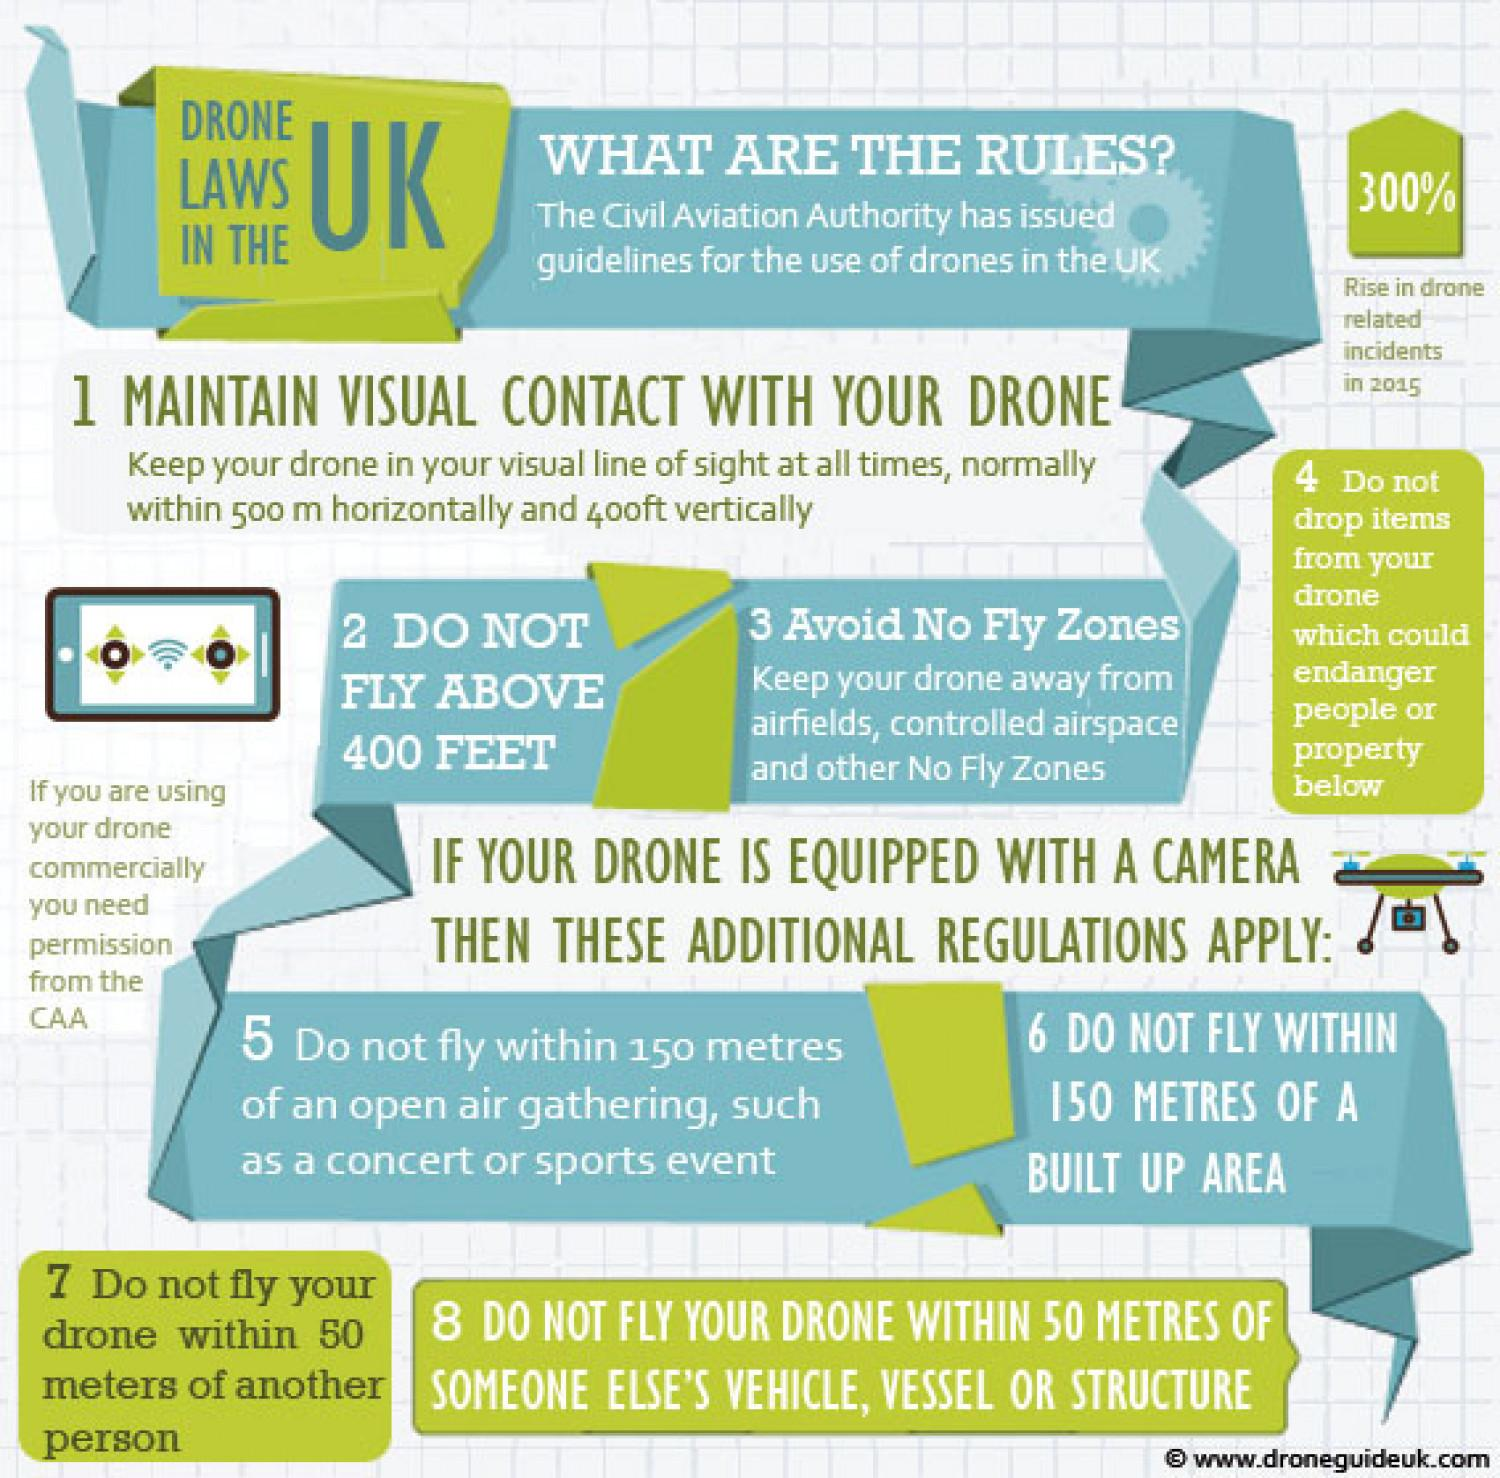Give some essential details in this illustration. The number of drone-related incidents in the UK increased by 300% in 2015. The Civil Aviation Authority is the authority responsible for granting permission for the use of drones in the United Kingdom. 